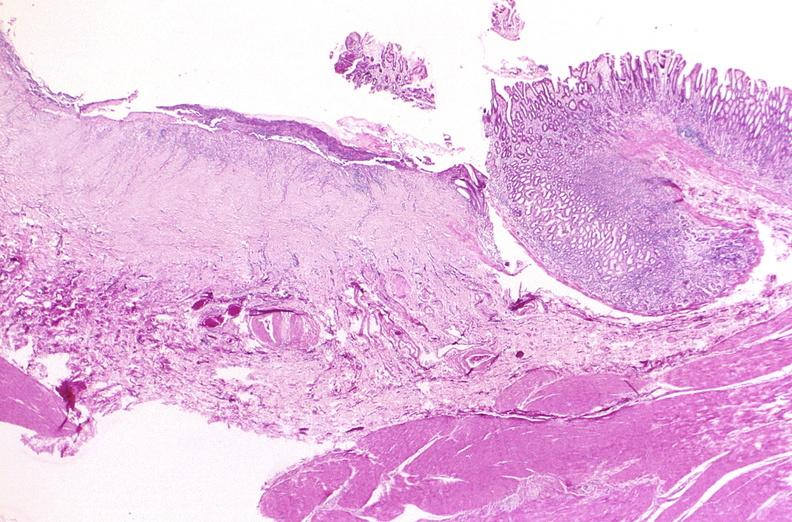does outside adrenal capsule section show stomach, chronic peptic ulcer?
Answer the question using a single word or phrase. No 